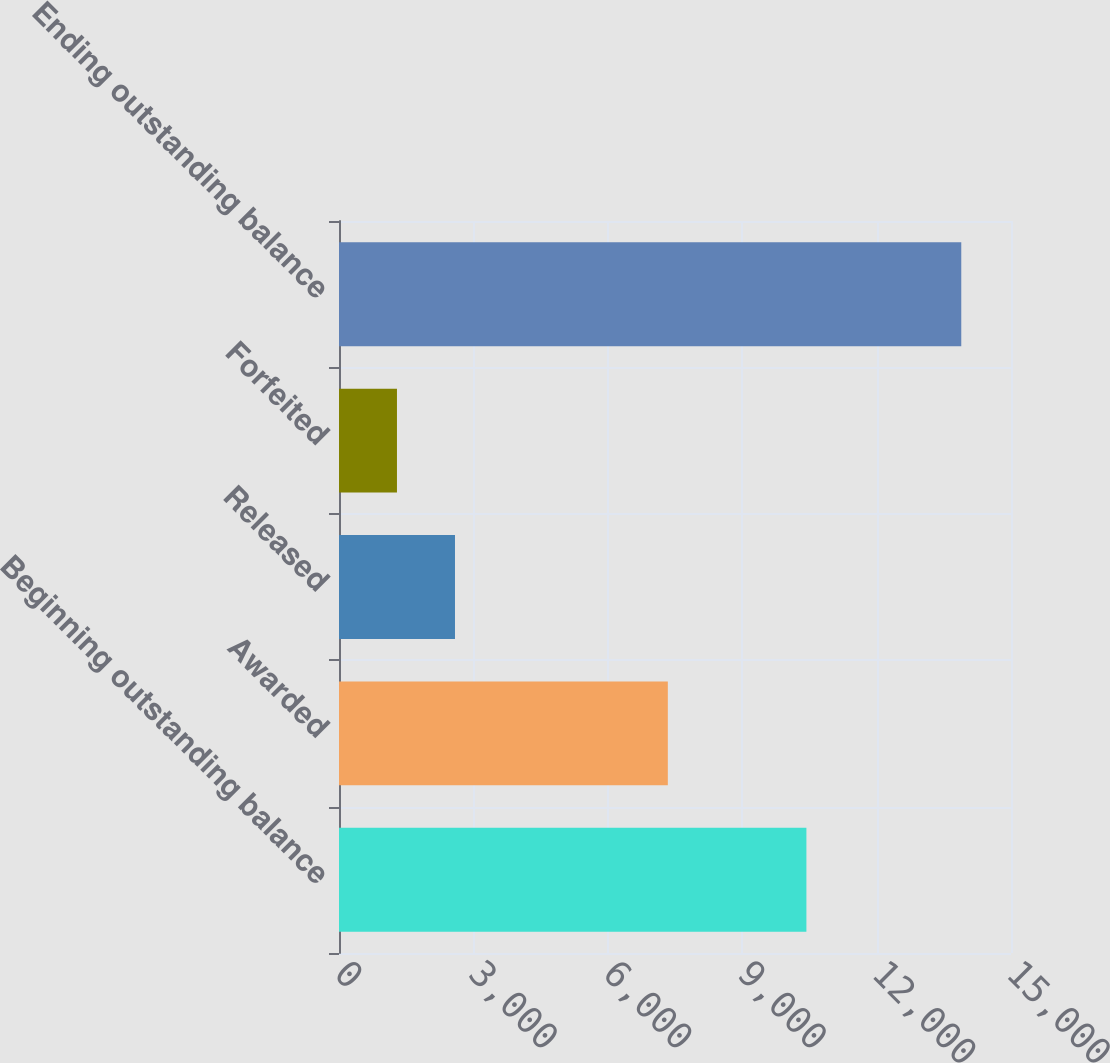<chart> <loc_0><loc_0><loc_500><loc_500><bar_chart><fcel>Beginning outstanding balance<fcel>Awarded<fcel>Released<fcel>Forfeited<fcel>Ending outstanding balance<nl><fcel>10433<fcel>7340<fcel>2589<fcel>1294<fcel>13890<nl></chart> 